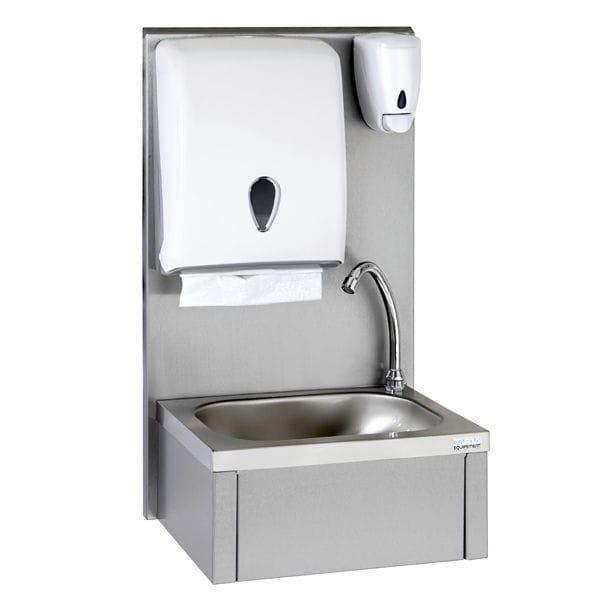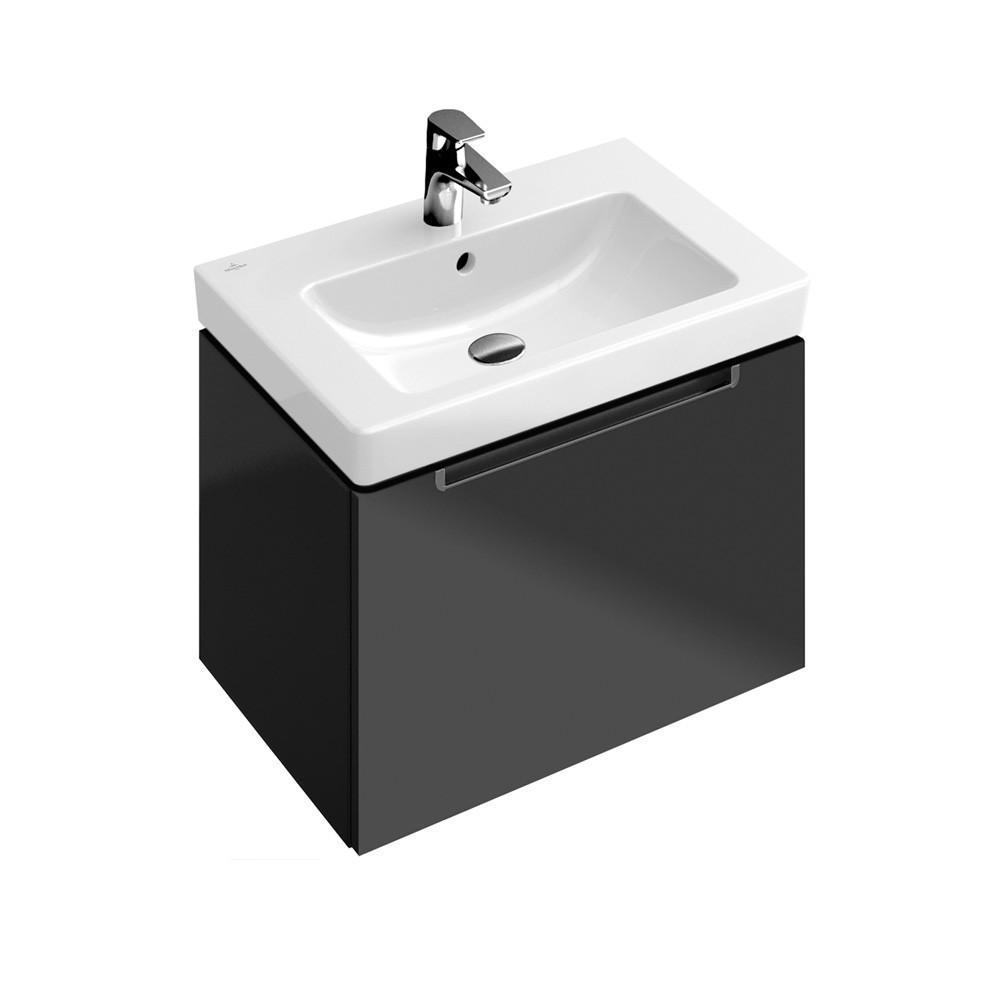The first image is the image on the left, the second image is the image on the right. Assess this claim about the two images: "There is a square white sink with single faucet on top and cabinet underneath.". Correct or not? Answer yes or no. Yes. The first image is the image on the left, the second image is the image on the right. For the images shown, is this caption "The sink in one image has a soap dispenser." true? Answer yes or no. Yes. 